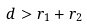<formula> <loc_0><loc_0><loc_500><loc_500>d > r _ { 1 } + r _ { 2 }</formula> 